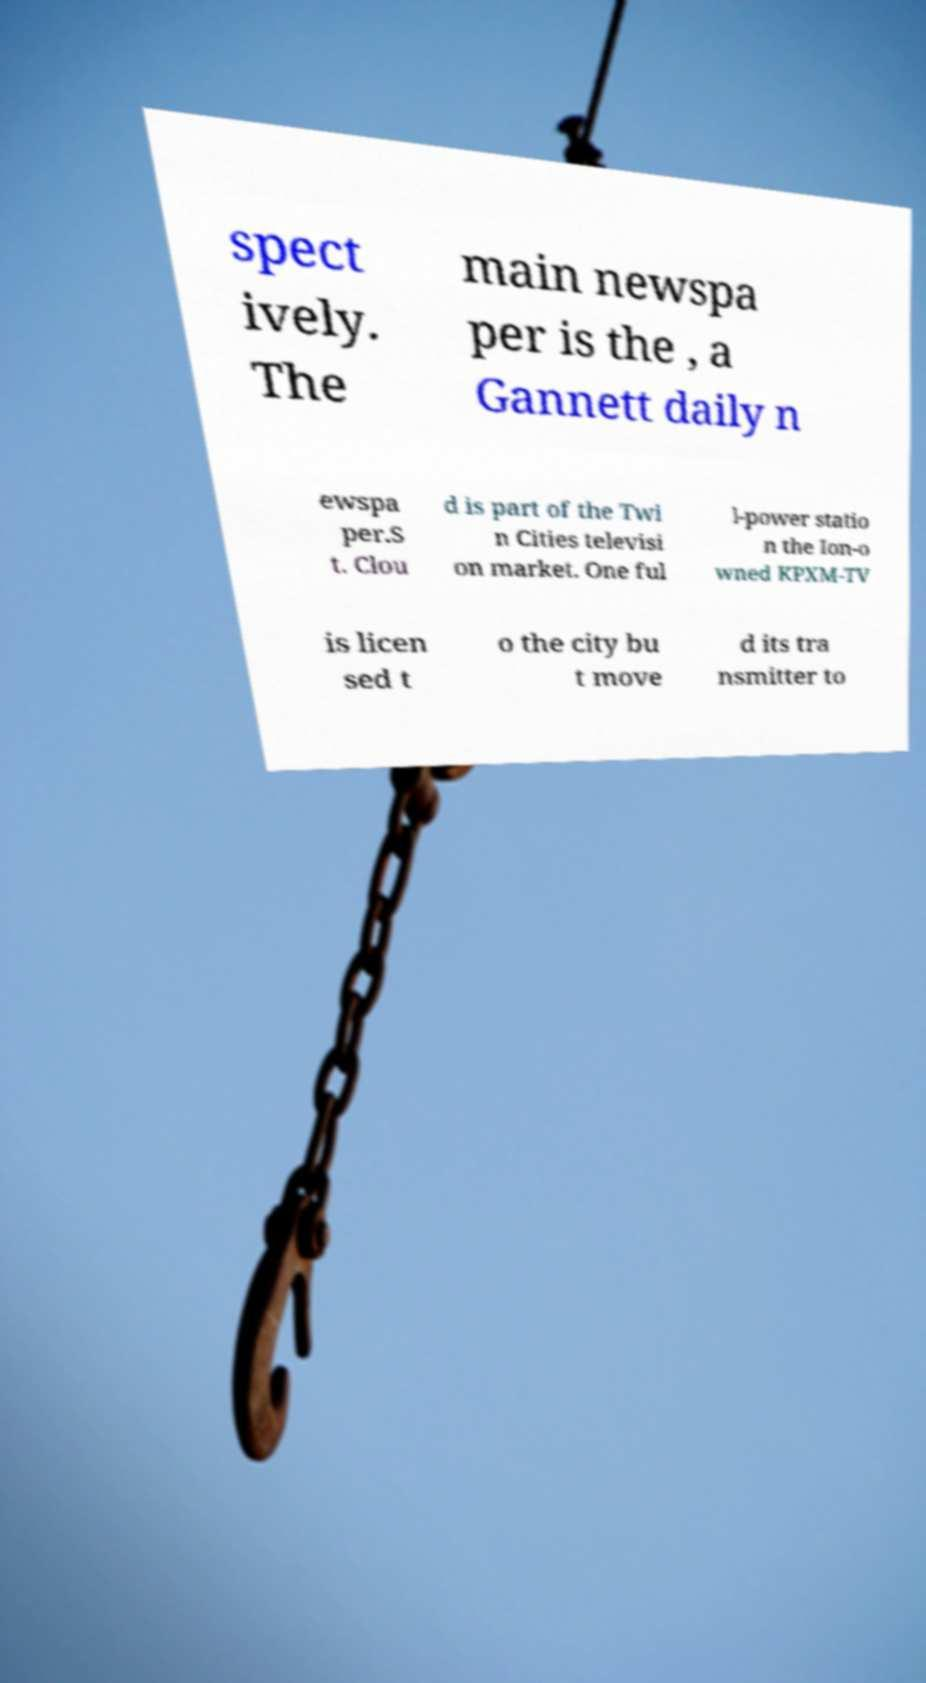Please identify and transcribe the text found in this image. spect ively. The main newspa per is the , a Gannett daily n ewspa per.S t. Clou d is part of the Twi n Cities televisi on market. One ful l-power statio n the Ion-o wned KPXM-TV is licen sed t o the city bu t move d its tra nsmitter to 